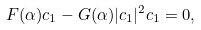<formula> <loc_0><loc_0><loc_500><loc_500>F ( \alpha ) c _ { 1 } - G ( \alpha ) | c _ { 1 } | ^ { 2 } c _ { 1 } = 0 ,</formula> 